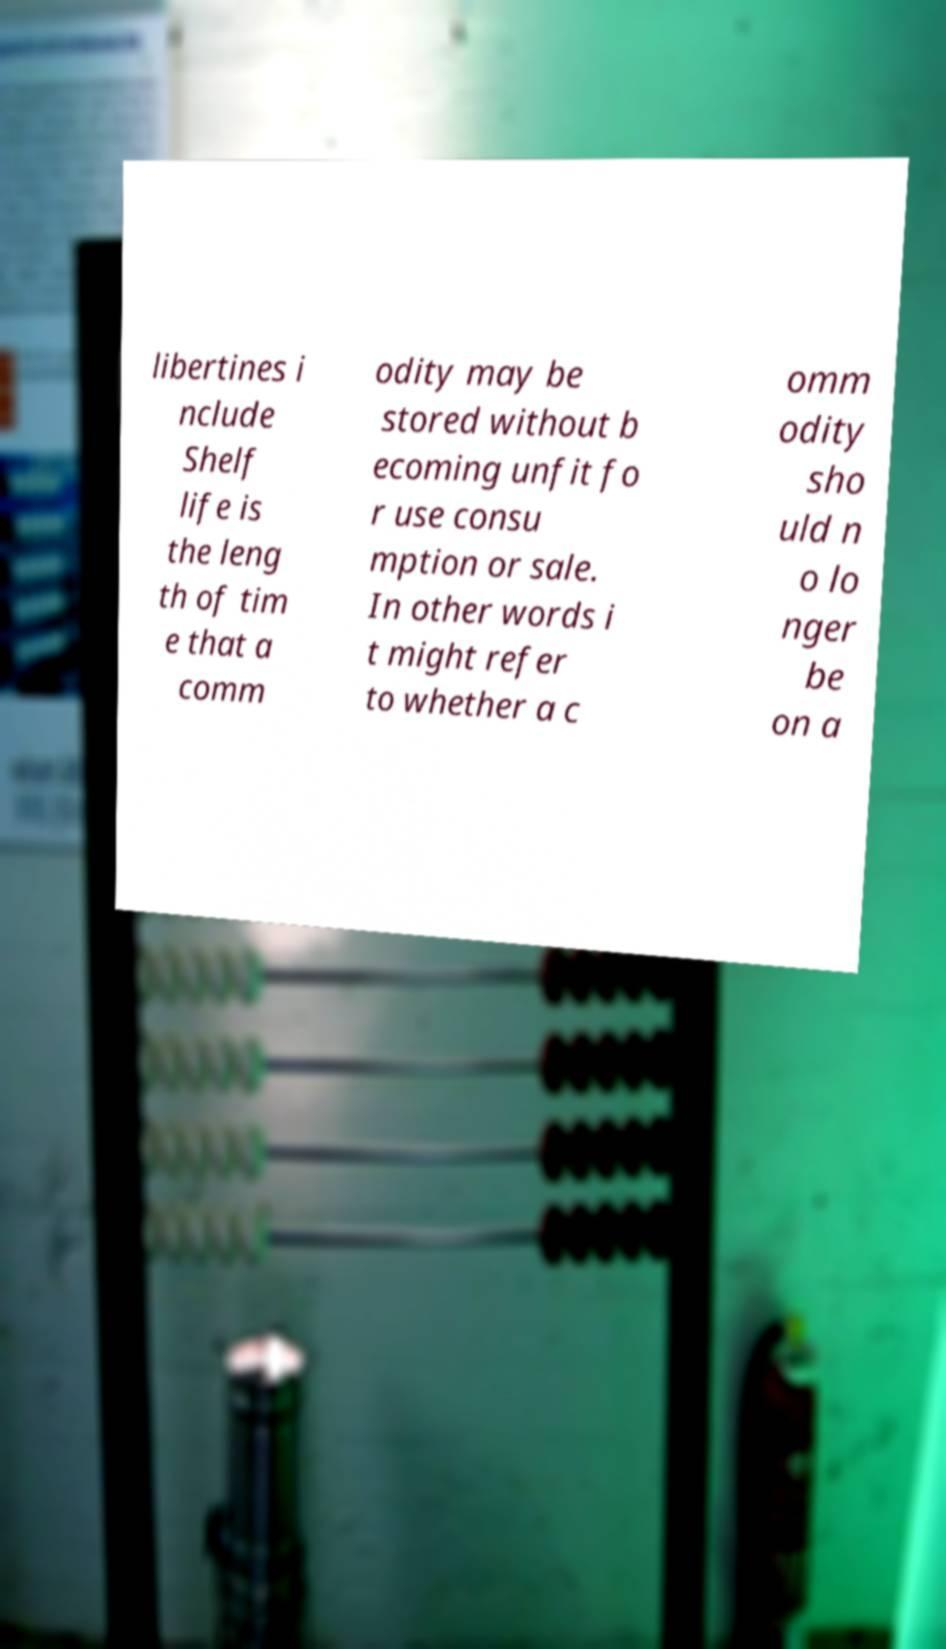I need the written content from this picture converted into text. Can you do that? libertines i nclude Shelf life is the leng th of tim e that a comm odity may be stored without b ecoming unfit fo r use consu mption or sale. In other words i t might refer to whether a c omm odity sho uld n o lo nger be on a 